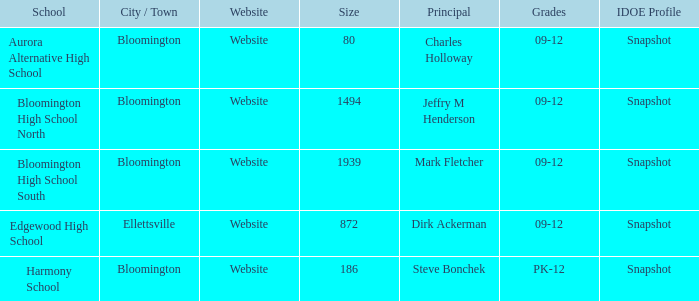Who holds the top position at edgewood high school? Dirk Ackerman. 